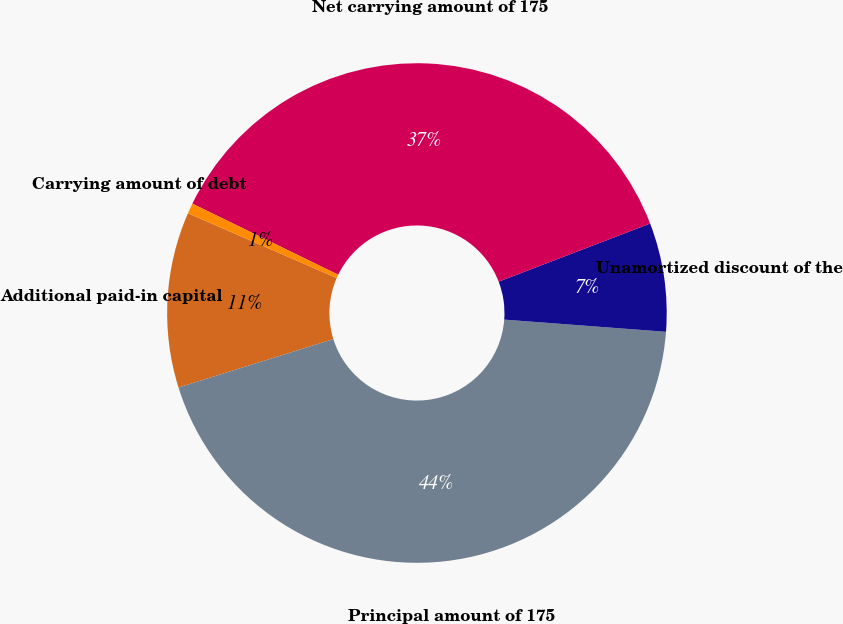Convert chart to OTSL. <chart><loc_0><loc_0><loc_500><loc_500><pie_chart><fcel>Additional paid-in capital<fcel>Principal amount of 175<fcel>Unamortized discount of the<fcel>Net carrying amount of 175<fcel>Carrying amount of debt<nl><fcel>11.36%<fcel>43.98%<fcel>7.03%<fcel>36.95%<fcel>0.67%<nl></chart> 